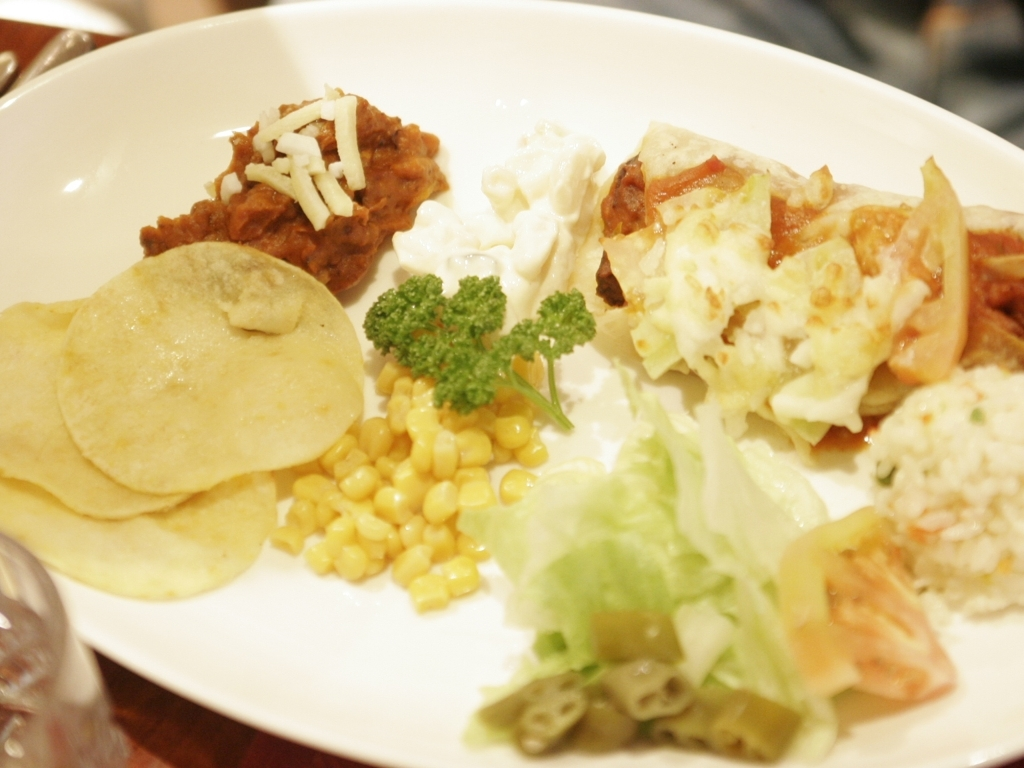What types of food can you identify on this plate? On the plate, there appears to be a variety of foods that suggest a mix of cuisines. There's some corn, what looks like refried beans topped with cheese, possibly a piece of flatbread or tortilla, a creamy salad that could contain potatoes, chunks of tomato and lettuce suggesting a sort of tossed salad, and a scoop of rice that might have some herbs mixed in. Can you provide some tips on how this presentation of food could be improved? Certainly! First, consider using dishes of different sizes to separate components and create visual interest. Incorporate a garnish to add a pop of color. Arrange the main elements in odd numbers for a more natural look, and leave a bit of space between different types of food to prevent the colors from bleeding into each other. Lastly, a clean rim on the plate can give the presentation a professional touch. 